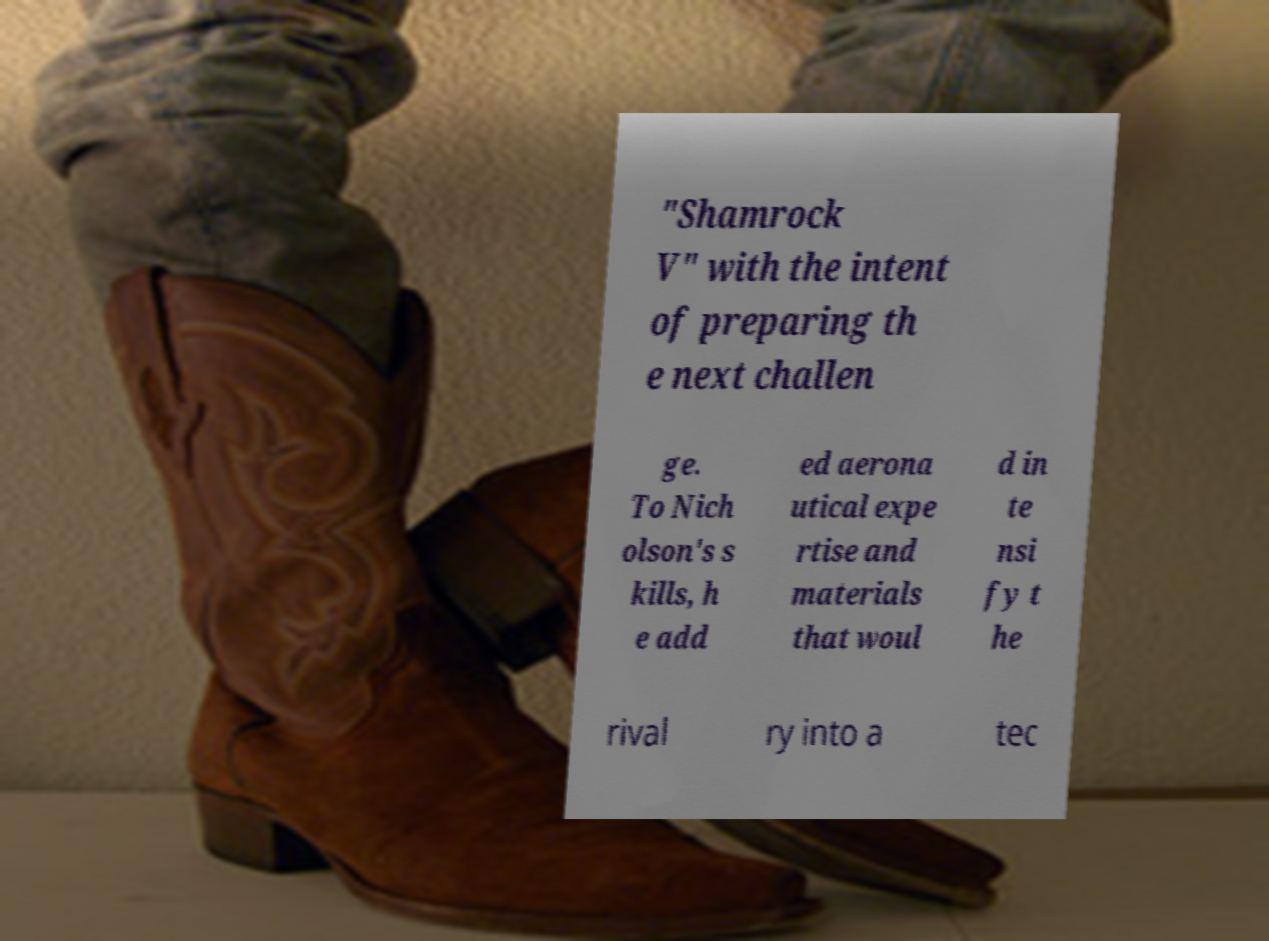I need the written content from this picture converted into text. Can you do that? "Shamrock V" with the intent of preparing th e next challen ge. To Nich olson's s kills, h e add ed aerona utical expe rtise and materials that woul d in te nsi fy t he rival ry into a tec 